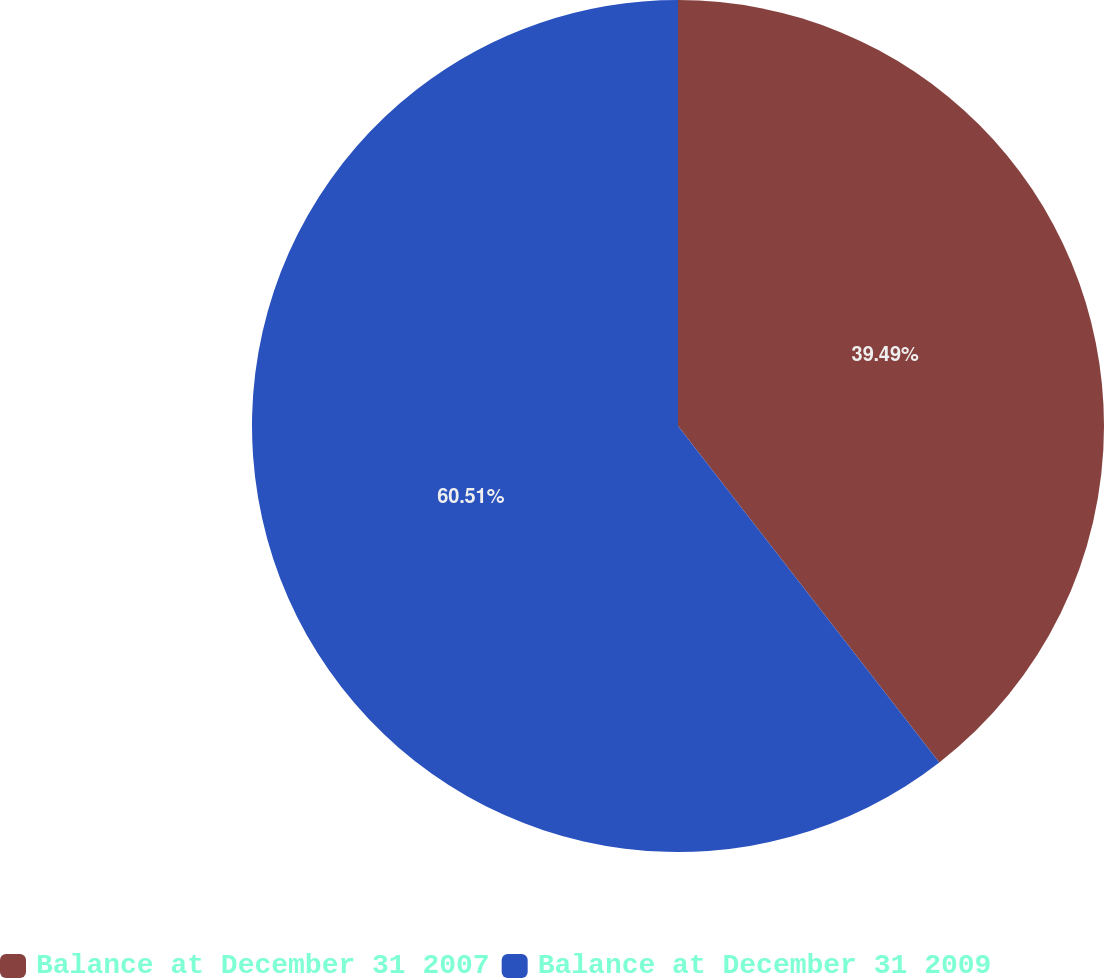Convert chart to OTSL. <chart><loc_0><loc_0><loc_500><loc_500><pie_chart><fcel>Balance at December 31 2007<fcel>Balance at December 31 2009<nl><fcel>39.49%<fcel>60.51%<nl></chart> 